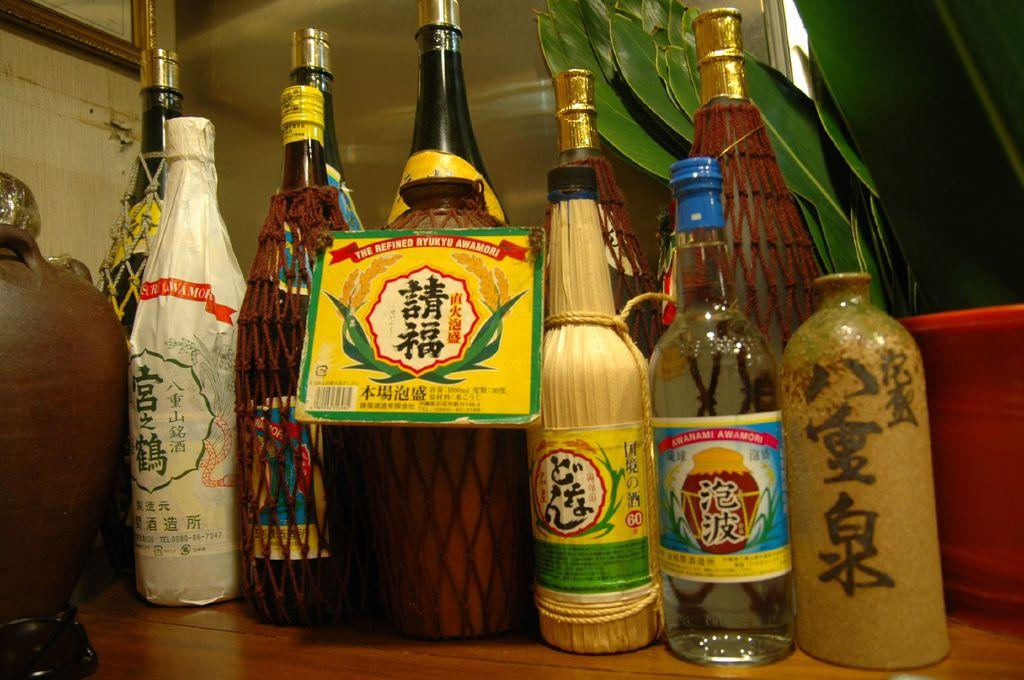<image>
Offer a succinct explanation of the picture presented. some Japanese writing that is on some different bottles 